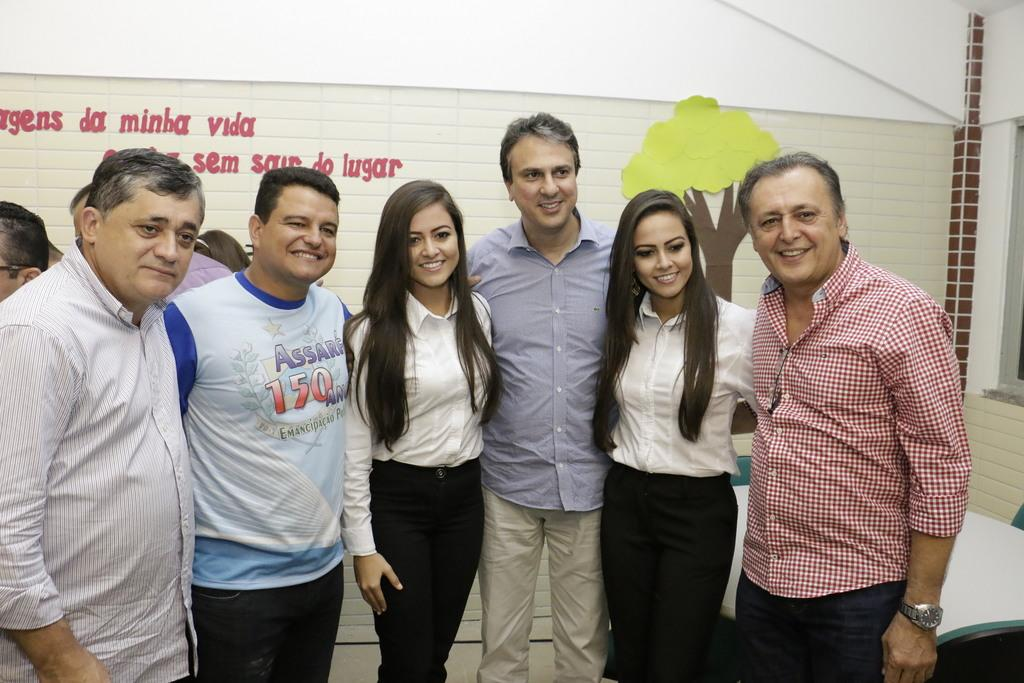What are the people in the image doing? The people in the image are standing and taking a picture. What can be seen in the background of the image? There is a table visible in the background, and there are people in the background as well. What is on the wall in the image? There is a banner on the wall in the image. What type of rub can be seen on the people's hands in the image? There is no rub visible on the people's hands in the image. Can you see any bats in the image? There are no bats present in the image. 